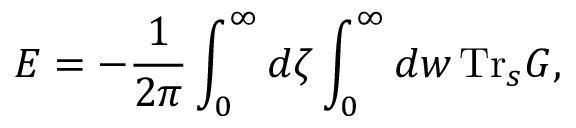<formula> <loc_0><loc_0><loc_500><loc_500>E = - { \frac { 1 } { 2 \pi } } \int _ { 0 } ^ { \infty } d \zeta \int _ { 0 } ^ { \infty } d w \, T r _ { s } G ,</formula> 